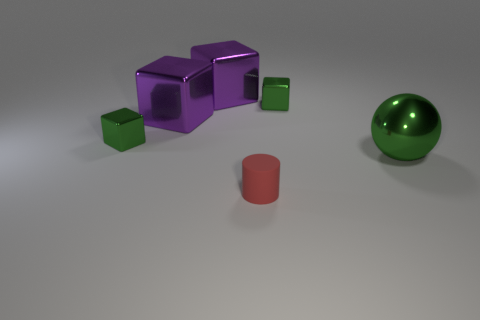Add 1 purple metal cubes. How many objects exist? 7 Subtract all cylinders. How many objects are left? 5 Subtract all tiny blue cylinders. Subtract all tiny green cubes. How many objects are left? 4 Add 3 shiny balls. How many shiny balls are left? 4 Add 2 big matte cylinders. How many big matte cylinders exist? 2 Subtract 0 cyan balls. How many objects are left? 6 